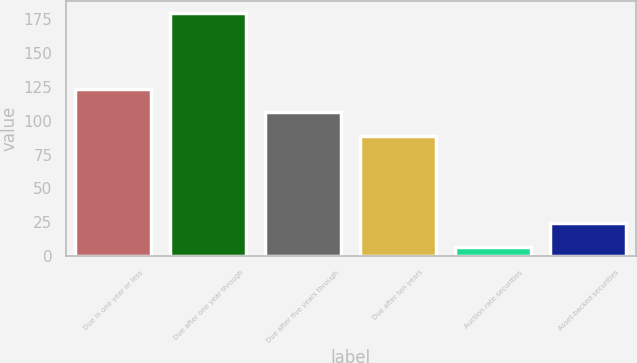Convert chart. <chart><loc_0><loc_0><loc_500><loc_500><bar_chart><fcel>Due in one year or less<fcel>Due after one year through<fcel>Due after five years through<fcel>Due after ten years<fcel>Auction rate securities<fcel>Asset-backed securities<nl><fcel>123.6<fcel>180<fcel>106.3<fcel>89<fcel>7<fcel>24.3<nl></chart> 